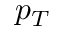<formula> <loc_0><loc_0><loc_500><loc_500>p _ { T }</formula> 